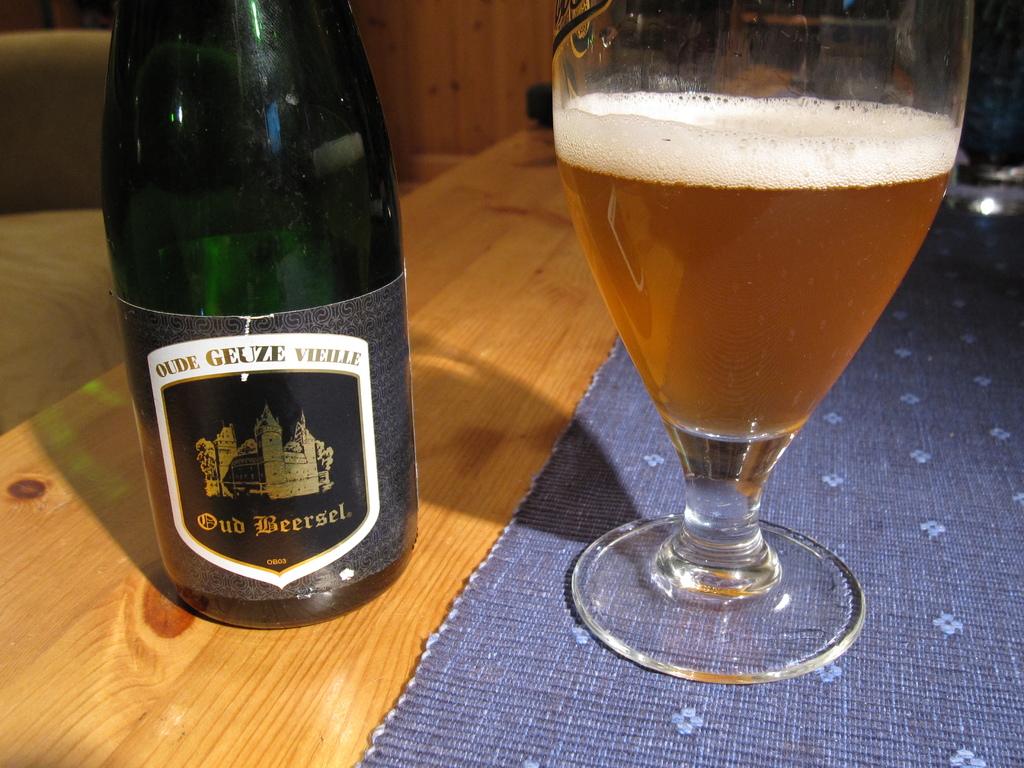What is the name of the drink?
Provide a succinct answer. Oud beersel. 